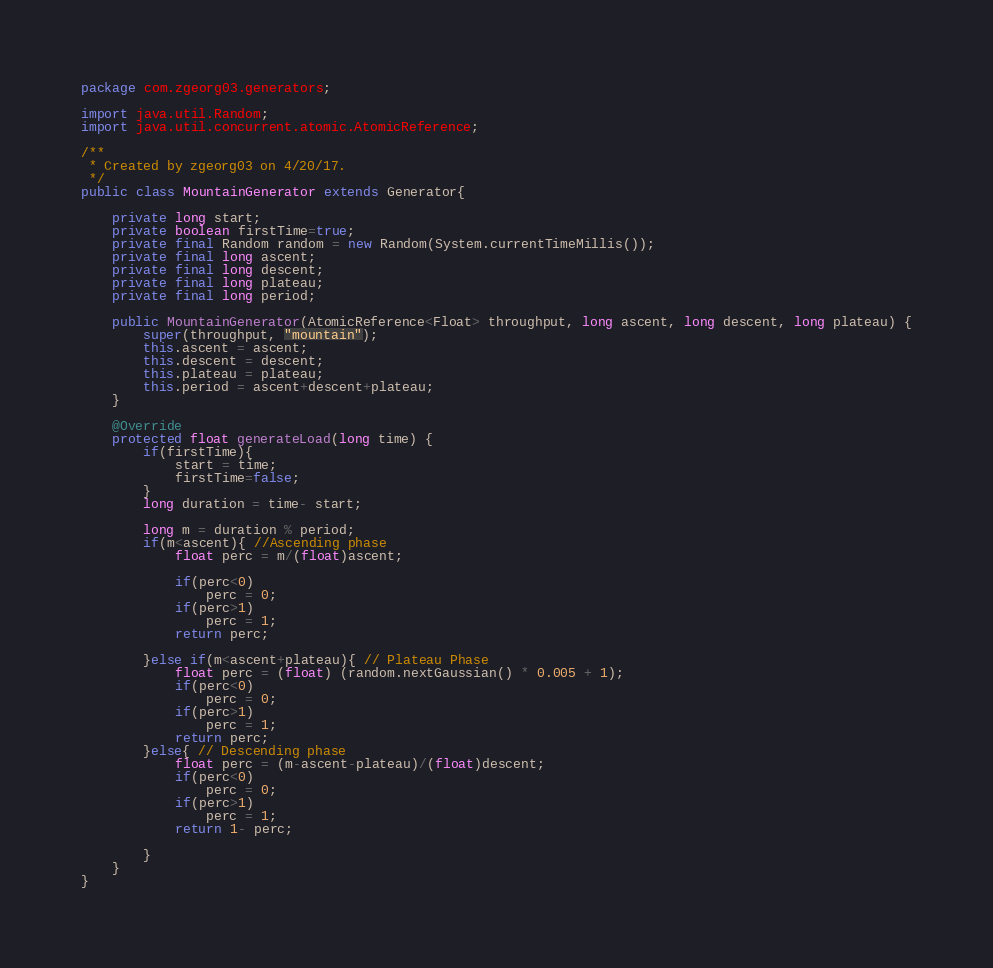Convert code to text. <code><loc_0><loc_0><loc_500><loc_500><_Java_>package com.zgeorg03.generators;

import java.util.Random;
import java.util.concurrent.atomic.AtomicReference;

/**
 * Created by zgeorg03 on 4/20/17.
 */
public class MountainGenerator extends Generator{

    private long start;
    private boolean firstTime=true;
    private final Random random = new Random(System.currentTimeMillis());
    private final long ascent;
    private final long descent;
    private final long plateau;
    private final long period;

    public MountainGenerator(AtomicReference<Float> throughput, long ascent, long descent, long plateau) {
        super(throughput, "mountain");
        this.ascent = ascent;
        this.descent = descent;
        this.plateau = plateau;
        this.period = ascent+descent+plateau;
    }

    @Override
    protected float generateLoad(long time) {
        if(firstTime){
            start = time;
            firstTime=false;
        }
        long duration = time- start;

        long m = duration % period;
        if(m<ascent){ //Ascending phase
            float perc = m/(float)ascent;

            if(perc<0)
                perc = 0;
            if(perc>1)
                perc = 1;
            return perc;

        }else if(m<ascent+plateau){ // Plateau Phase
            float perc = (float) (random.nextGaussian() * 0.005 + 1);
            if(perc<0)
                perc = 0;
            if(perc>1)
                perc = 1;
            return perc;
        }else{ // Descending phase
            float perc = (m-ascent-plateau)/(float)descent;
            if(perc<0)
                perc = 0;
            if(perc>1)
                perc = 1;
            return 1- perc;

        }
    }
}
</code> 